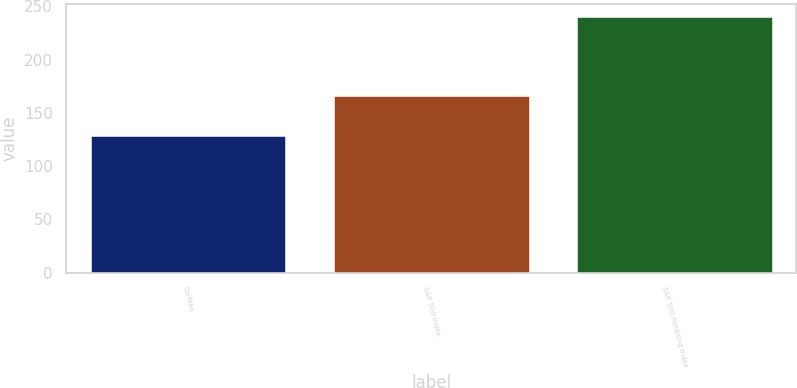<chart> <loc_0><loc_0><loc_500><loc_500><bar_chart><fcel>CarMax<fcel>S&P 500 Index<fcel>S&P 500 Retailing Index<nl><fcel>128.23<fcel>166<fcel>239.87<nl></chart> 